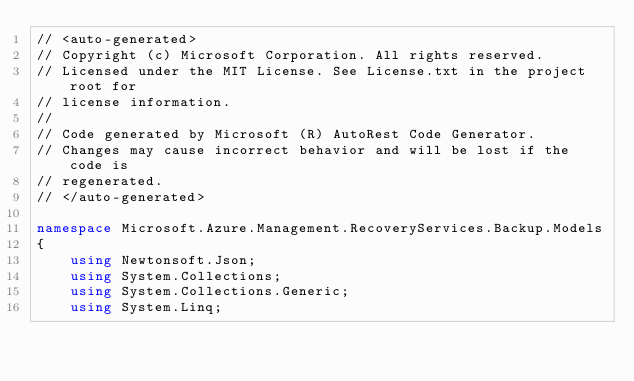<code> <loc_0><loc_0><loc_500><loc_500><_C#_>// <auto-generated>
// Copyright (c) Microsoft Corporation. All rights reserved.
// Licensed under the MIT License. See License.txt in the project root for
// license information.
//
// Code generated by Microsoft (R) AutoRest Code Generator.
// Changes may cause incorrect behavior and will be lost if the code is
// regenerated.
// </auto-generated>

namespace Microsoft.Azure.Management.RecoveryServices.Backup.Models
{
    using Newtonsoft.Json;
    using System.Collections;
    using System.Collections.Generic;
    using System.Linq;
</code> 